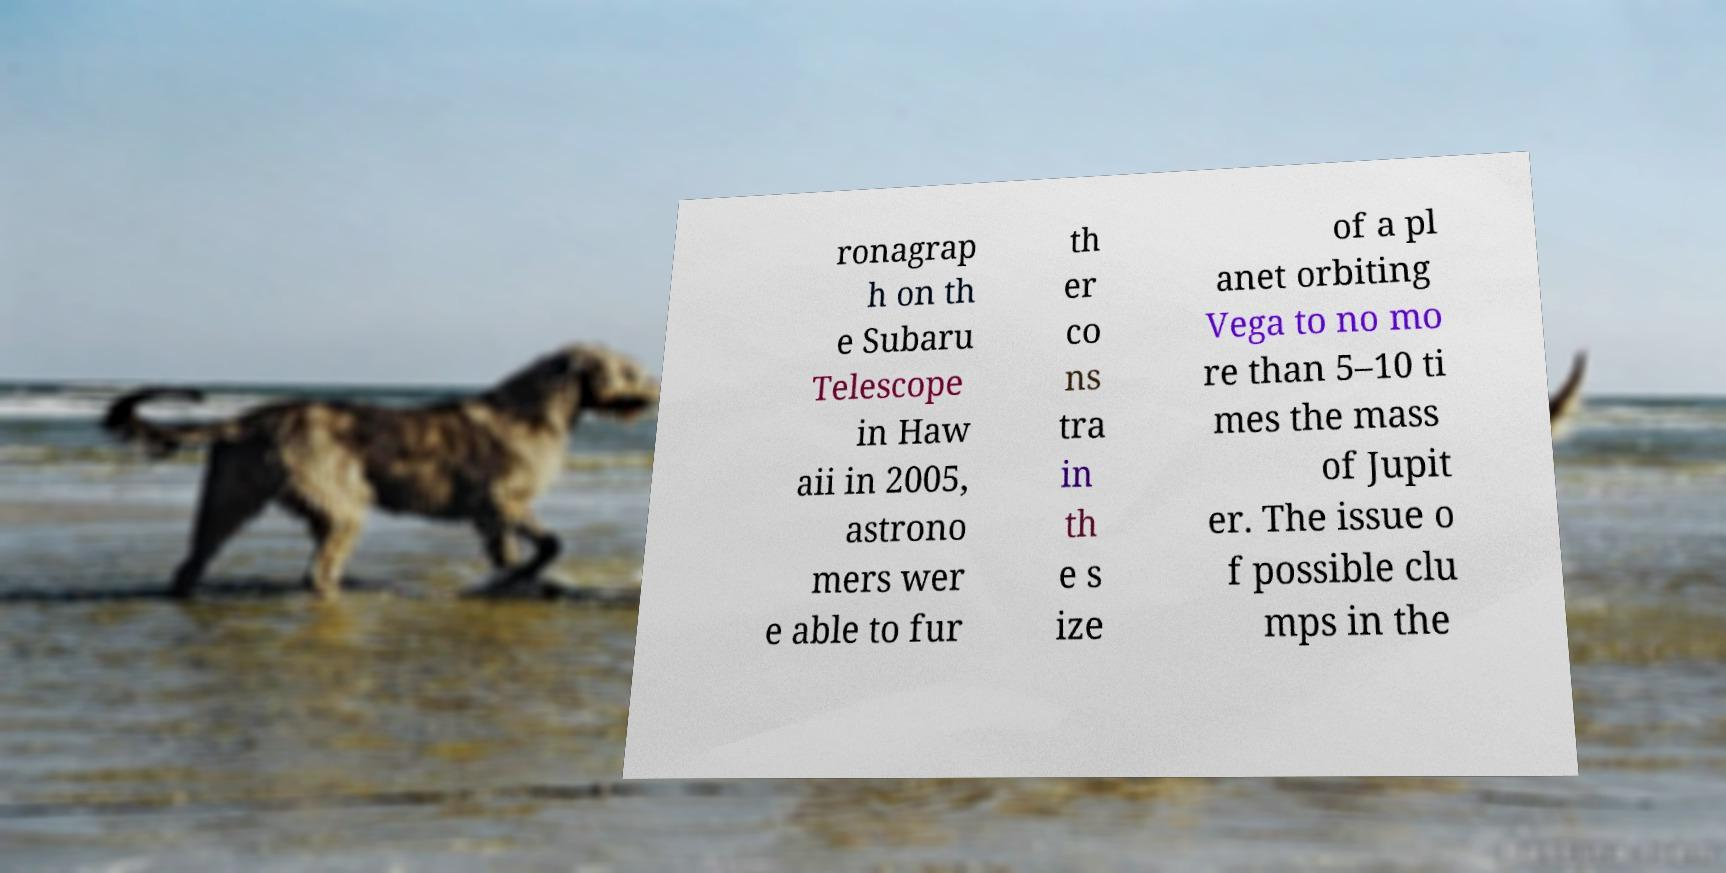I need the written content from this picture converted into text. Can you do that? ronagrap h on th e Subaru Telescope in Haw aii in 2005, astrono mers wer e able to fur th er co ns tra in th e s ize of a pl anet orbiting Vega to no mo re than 5–10 ti mes the mass of Jupit er. The issue o f possible clu mps in the 